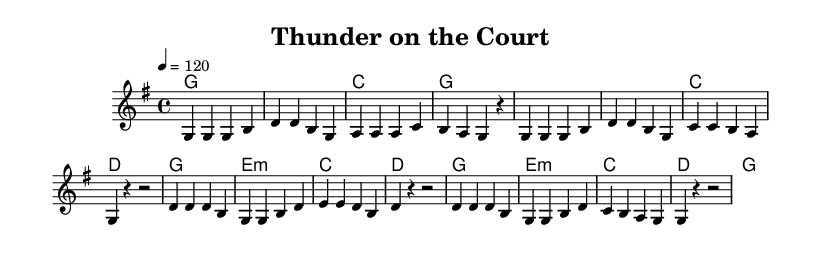What is the key signature of this music? The key signature is G major, indicated by the presence of one sharp (F#).
Answer: G major What is the time signature of this piece? The time signature is 4/4, which means there are four beats in each measure, and each quarter note gets one beat. This is confirmed by the notation at the beginning of the score.
Answer: 4/4 What is the tempo marking for this music? The tempo marking is quarter note equals 120, which indicates the speed of the piece, specifying that one quarter note should be played per beat at a rate of 120 beats per minute.
Answer: 120 How many measures are in the verse section? The verse consists of eight measures, as counted from the melody line. Each group of notes separated by vertical lines indicates a measure, and there are eight defined measures before the chorus begins.
Answer: 8 What is the primary chord played during the verse? The primary chord in the verse is G major, which is played for the first four measures and constructed to provide a strong foundation for the melody.
Answer: G What types of chords are used in the chorus? The chorus utilizes a mix of major and minor chords, specifically the G major, E minor, and D major, creating a dynamic contrast and harmonic depth typical in country anthems.
Answer: Major and minor What lyrical theme is suggested by the upbeat nature of this anthem? The lyrical theme suggests teamwork and camaraderie, as indicated by the title "Thunder on the Court" and the uplifting melody that evokes a sense of unity and celebration.
Answer: Teamwork and camaraderie 